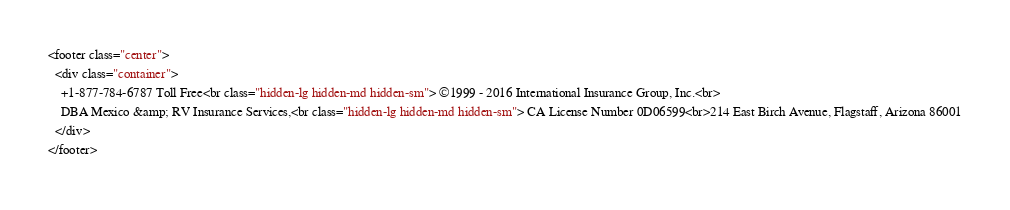<code> <loc_0><loc_0><loc_500><loc_500><_HTML_><footer class="center">
  <div class="container">
    +1-877-784-6787 Toll Free<br class="hidden-lg hidden-md hidden-sm"> ©1999 - 2016 International Insurance Group, Inc.<br>
    DBA Mexico &amp; RV Insurance Services,<br class="hidden-lg hidden-md hidden-sm"> CA License Number 0D06599<br>214 East Birch Avenue, Flagstaff, Arizona 86001
  </div>
</footer></code> 